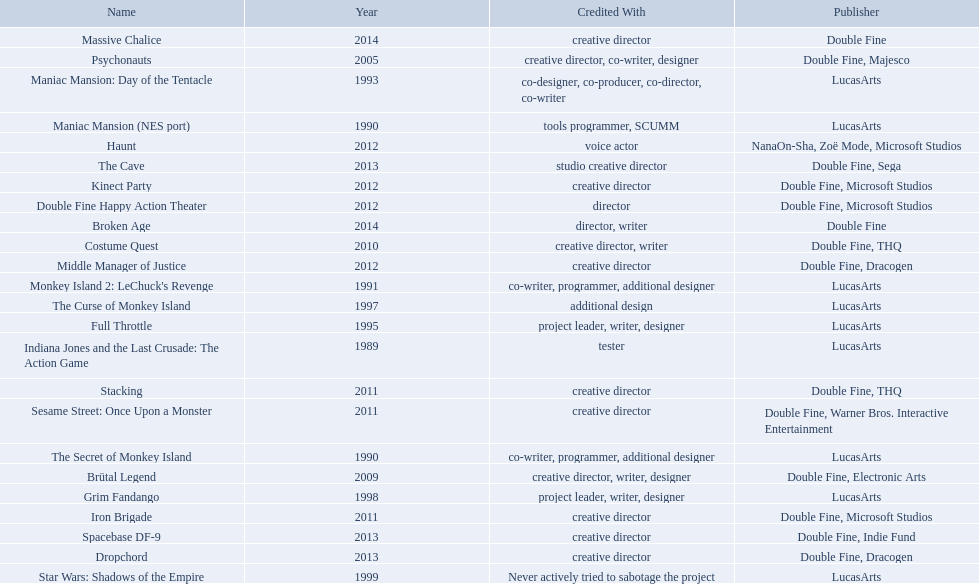What game name has tim schafer been involved with? Indiana Jones and the Last Crusade: The Action Game, Maniac Mansion (NES port), The Secret of Monkey Island, Monkey Island 2: LeChuck's Revenge, Maniac Mansion: Day of the Tentacle, Full Throttle, The Curse of Monkey Island, Grim Fandango, Star Wars: Shadows of the Empire, Psychonauts, Brütal Legend, Costume Quest, Stacking, Iron Brigade, Sesame Street: Once Upon a Monster, Haunt, Double Fine Happy Action Theater, Middle Manager of Justice, Kinect Party, The Cave, Dropchord, Spacebase DF-9, Broken Age, Massive Chalice. Which game has credit with just creative director? Creative director, creative director, creative director, creative director, creative director, creative director, creative director, creative director. Which games have the above and warner bros. interactive entertainment as publisher? Sesame Street: Once Upon a Monster. 